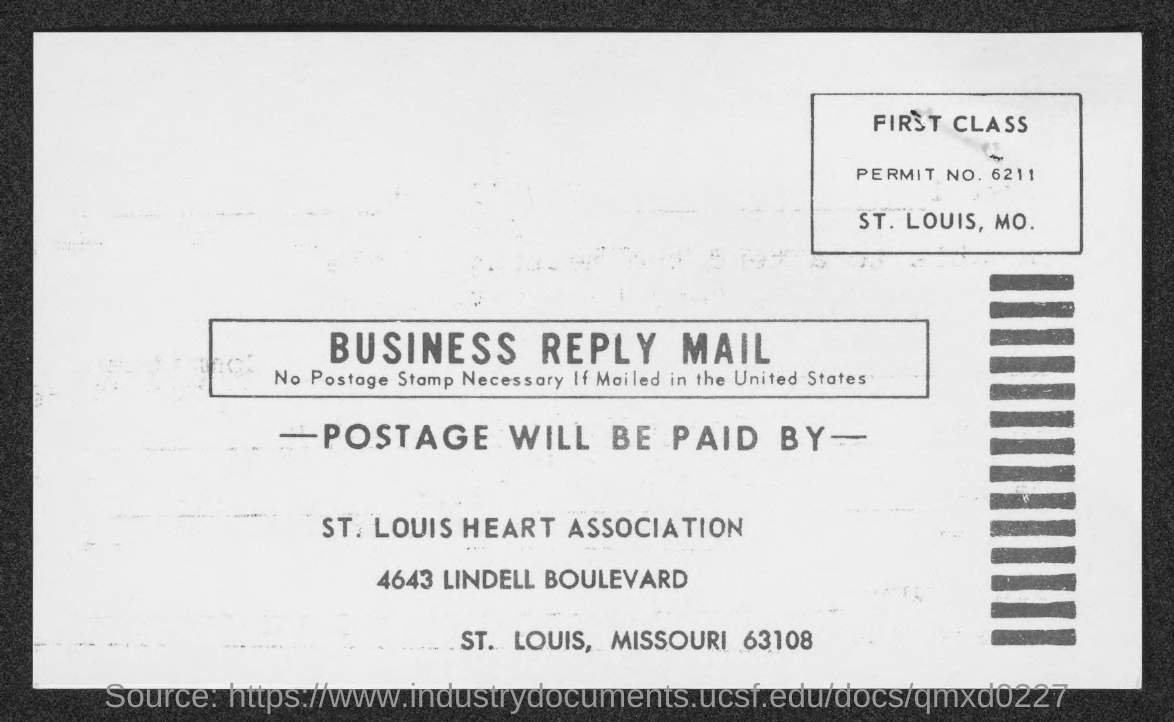Draw attention to some important aspects in this diagram. The permit number is 6211. The St. Louis Heat Association is located in which county. 